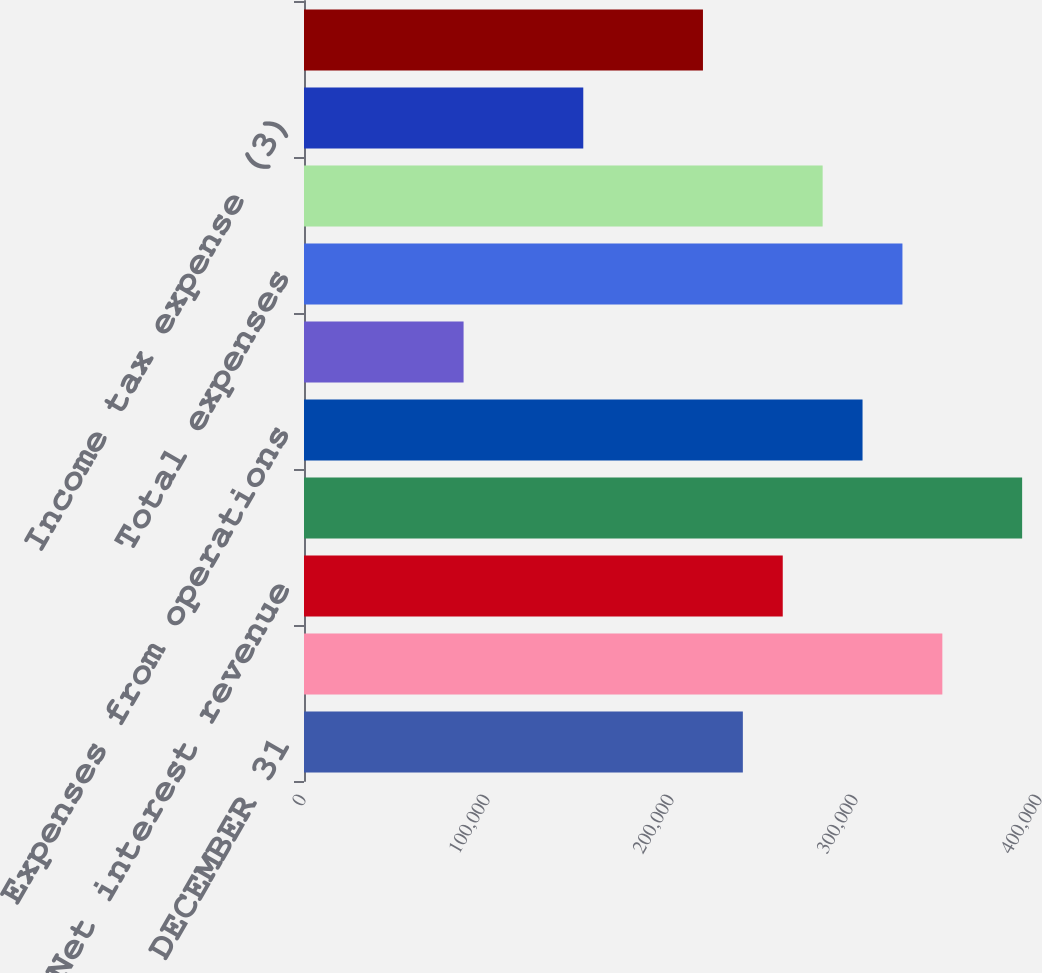Convert chart. <chart><loc_0><loc_0><loc_500><loc_500><bar_chart><fcel>FOR THE YEAR ENDED DECEMBER 31<fcel>Total fee revenue<fcel>Net interest revenue<fcel>Total revenue<fcel>Expenses from operations<fcel>Acquisition costs net (2)<fcel>Total expenses<fcel>Income before income tax<fcel>Income tax expense (3)<fcel>Income before extraordinary<nl><fcel>238510<fcel>346923<fcel>260192<fcel>390288<fcel>303558<fcel>86731.2<fcel>325240<fcel>281875<fcel>151779<fcel>216827<nl></chart> 